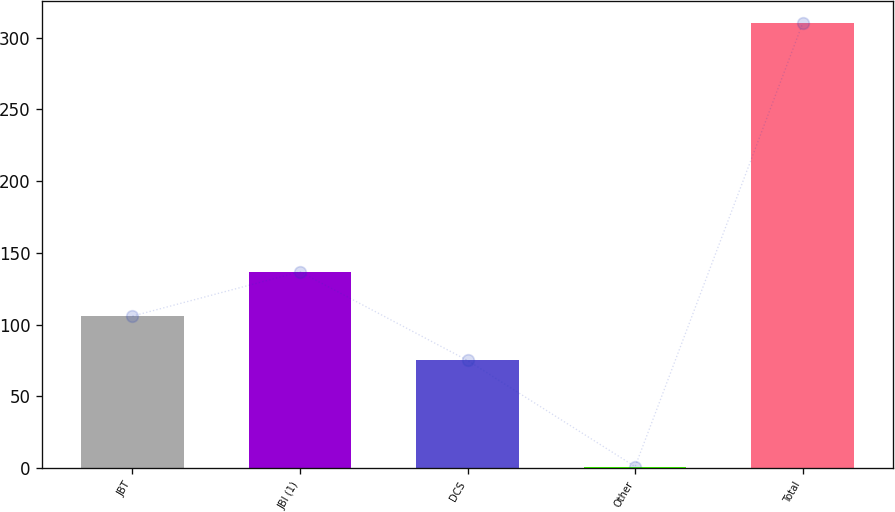<chart> <loc_0><loc_0><loc_500><loc_500><bar_chart><fcel>JBT<fcel>JBI (1)<fcel>DCS<fcel>Other<fcel>Total<nl><fcel>105.9<fcel>136.8<fcel>75<fcel>1<fcel>310<nl></chart> 